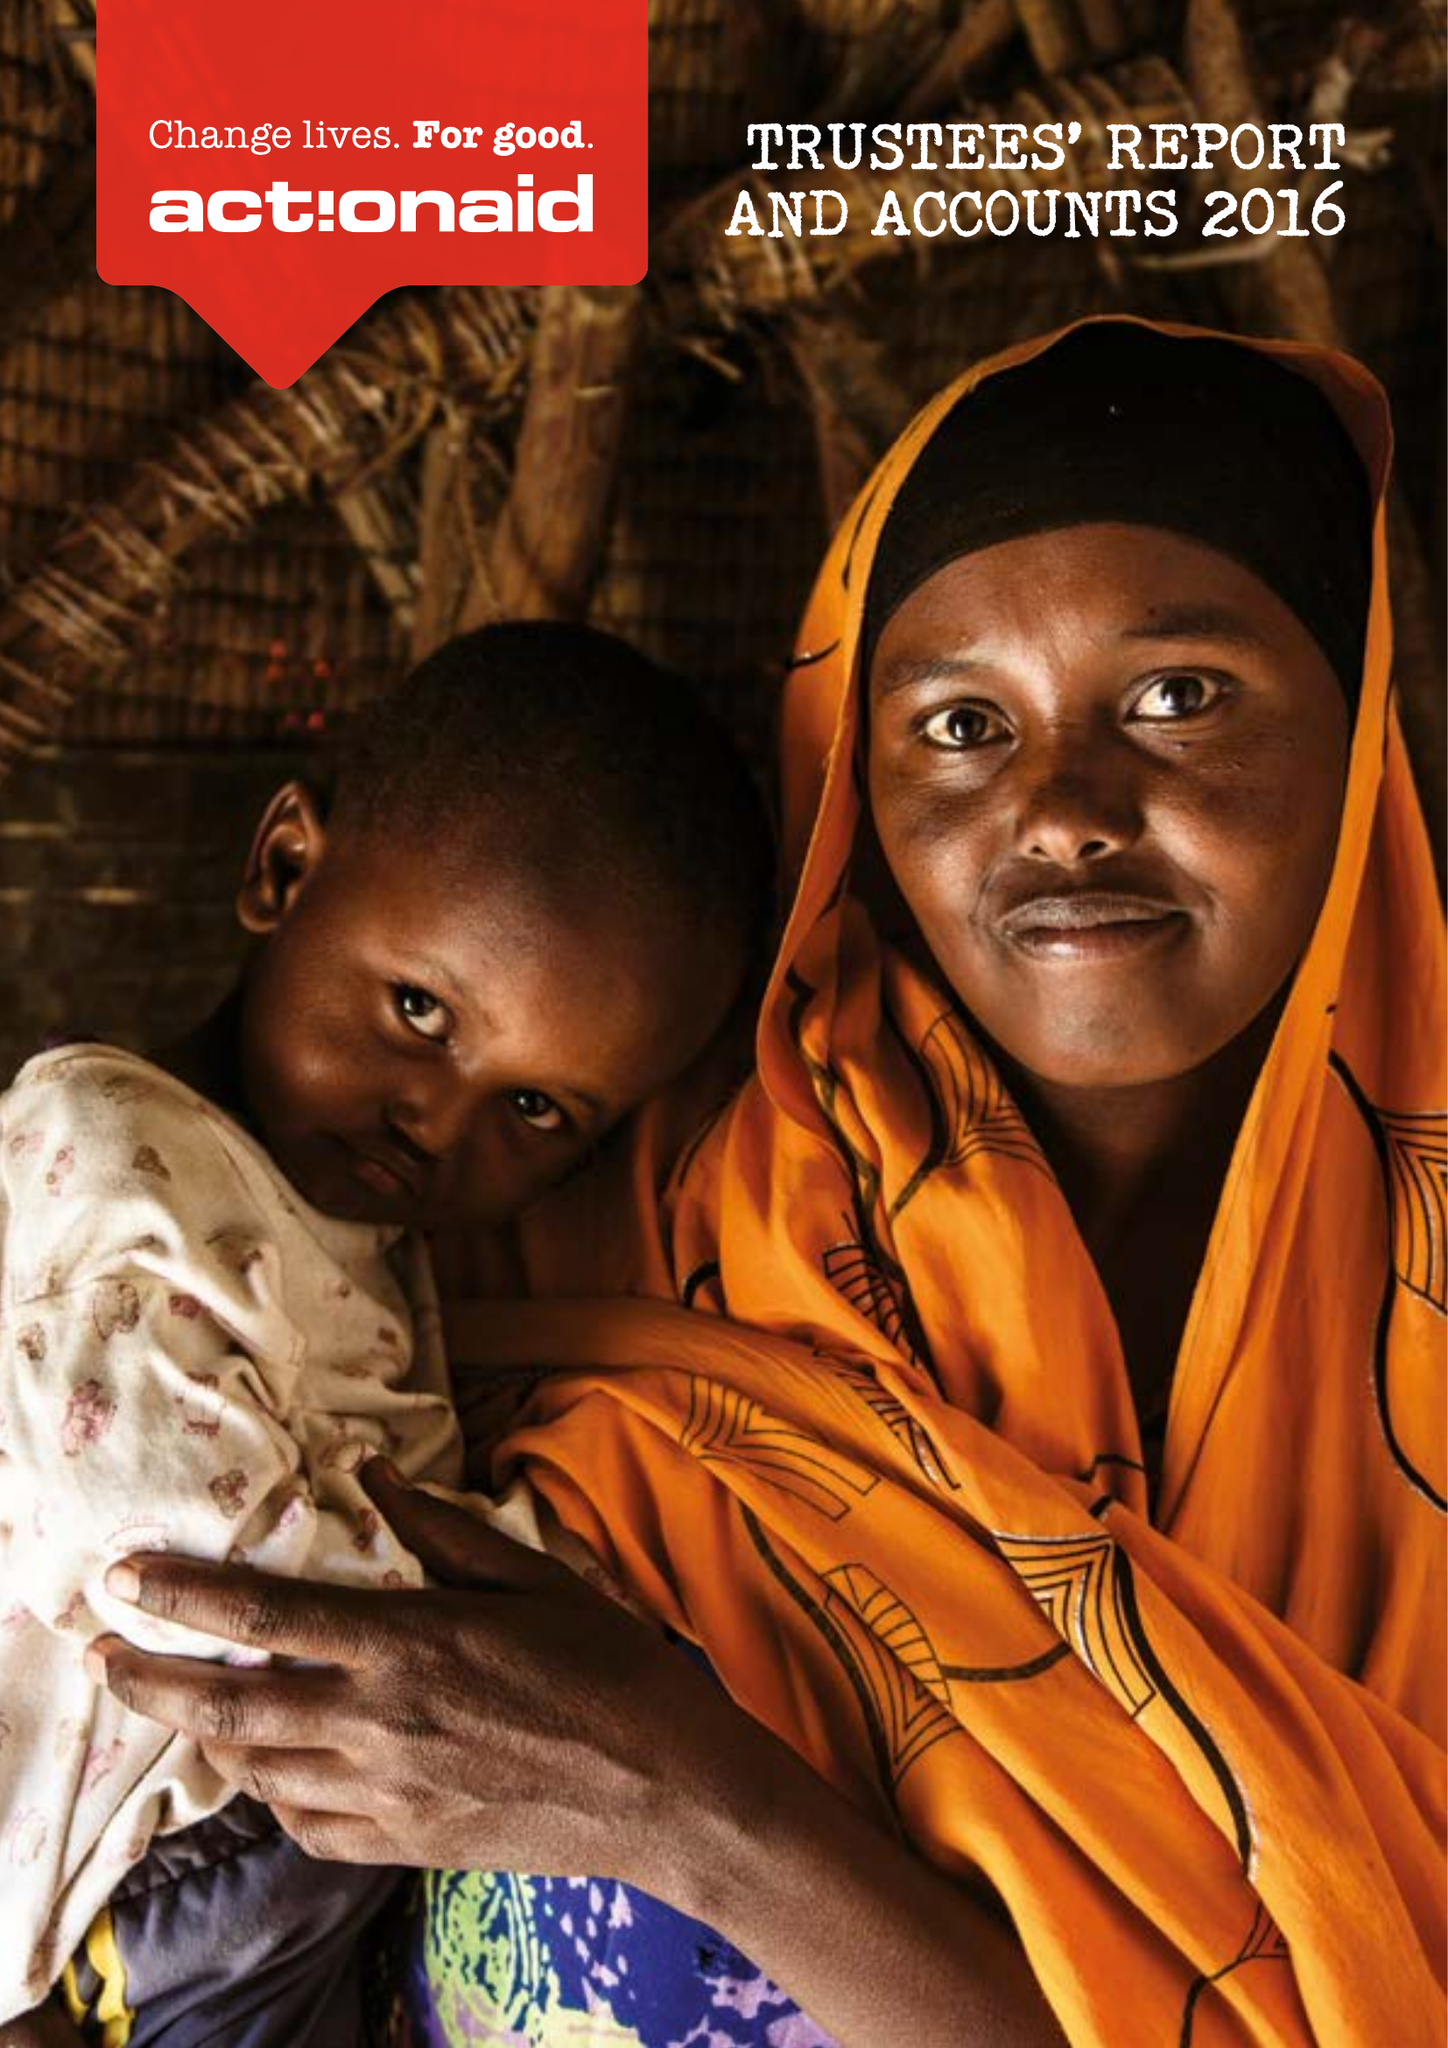What is the value for the address__postcode?
Answer the question using a single word or phrase. EC1R 0BJ 